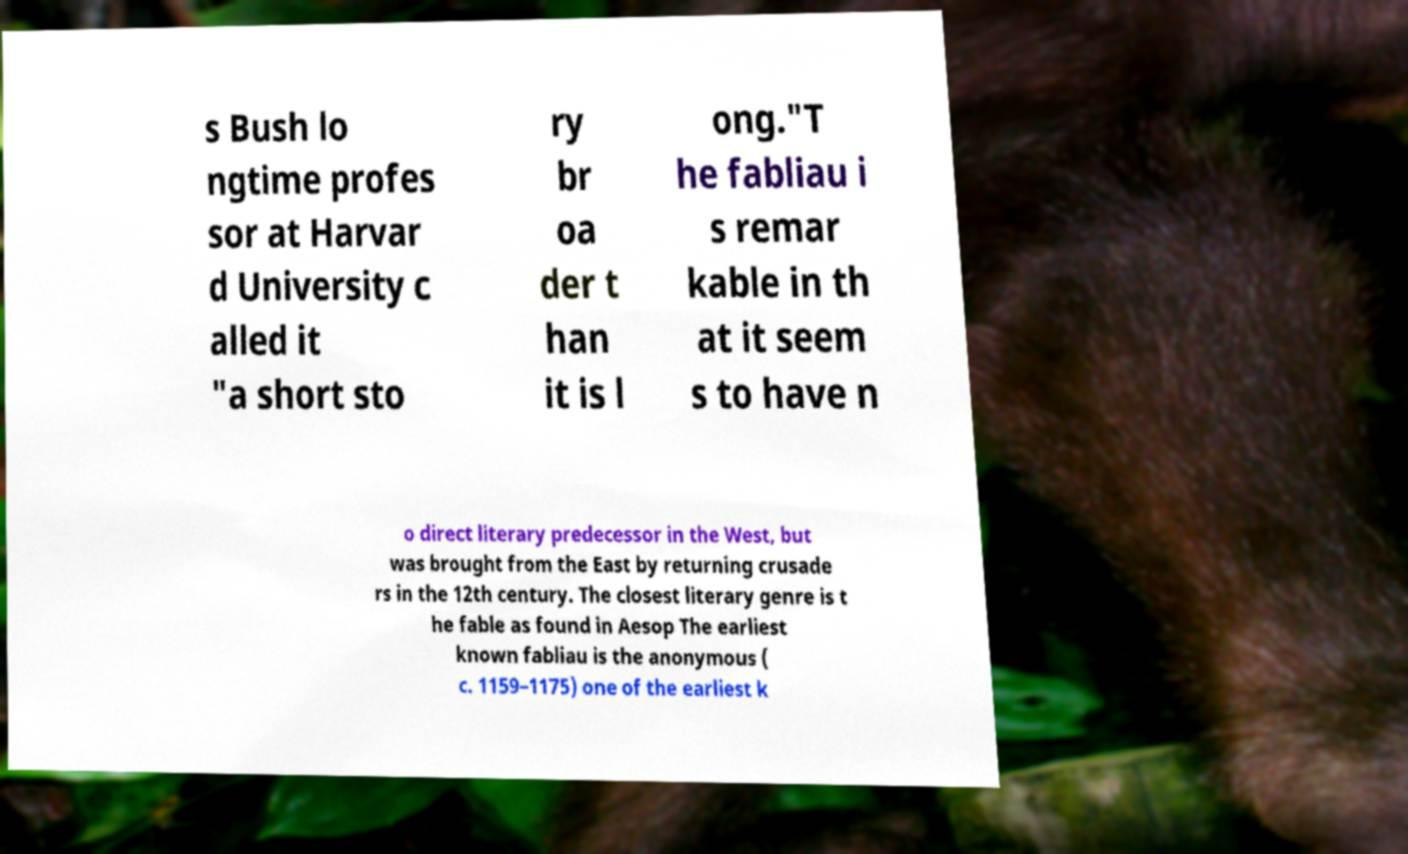There's text embedded in this image that I need extracted. Can you transcribe it verbatim? s Bush lo ngtime profes sor at Harvar d University c alled it "a short sto ry br oa der t han it is l ong."T he fabliau i s remar kable in th at it seem s to have n o direct literary predecessor in the West, but was brought from the East by returning crusade rs in the 12th century. The closest literary genre is t he fable as found in Aesop The earliest known fabliau is the anonymous ( c. 1159–1175) one of the earliest k 